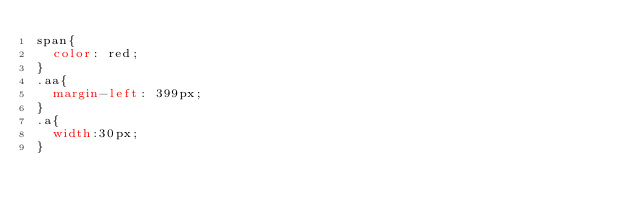<code> <loc_0><loc_0><loc_500><loc_500><_CSS_>span{
  color: red;
}
.aa{
  margin-left: 399px;
}
.a{
  width:30px;
}
</code> 